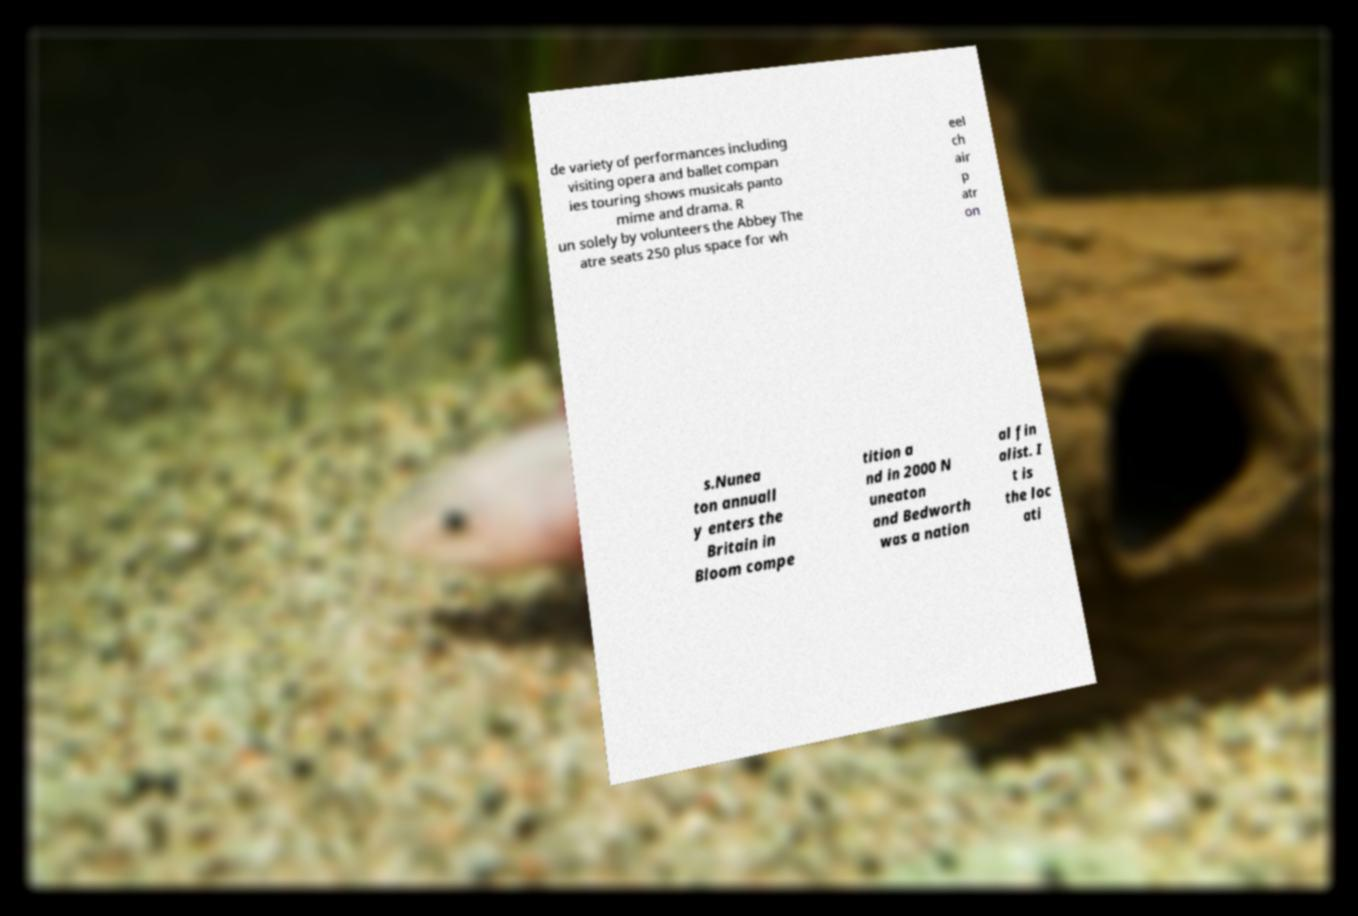Can you read and provide the text displayed in the image?This photo seems to have some interesting text. Can you extract and type it out for me? de variety of performances including visiting opera and ballet compan ies touring shows musicals panto mime and drama. R un solely by volunteers the Abbey The atre seats 250 plus space for wh eel ch air p atr on s.Nunea ton annuall y enters the Britain in Bloom compe tition a nd in 2000 N uneaton and Bedworth was a nation al fin alist. I t is the loc ati 